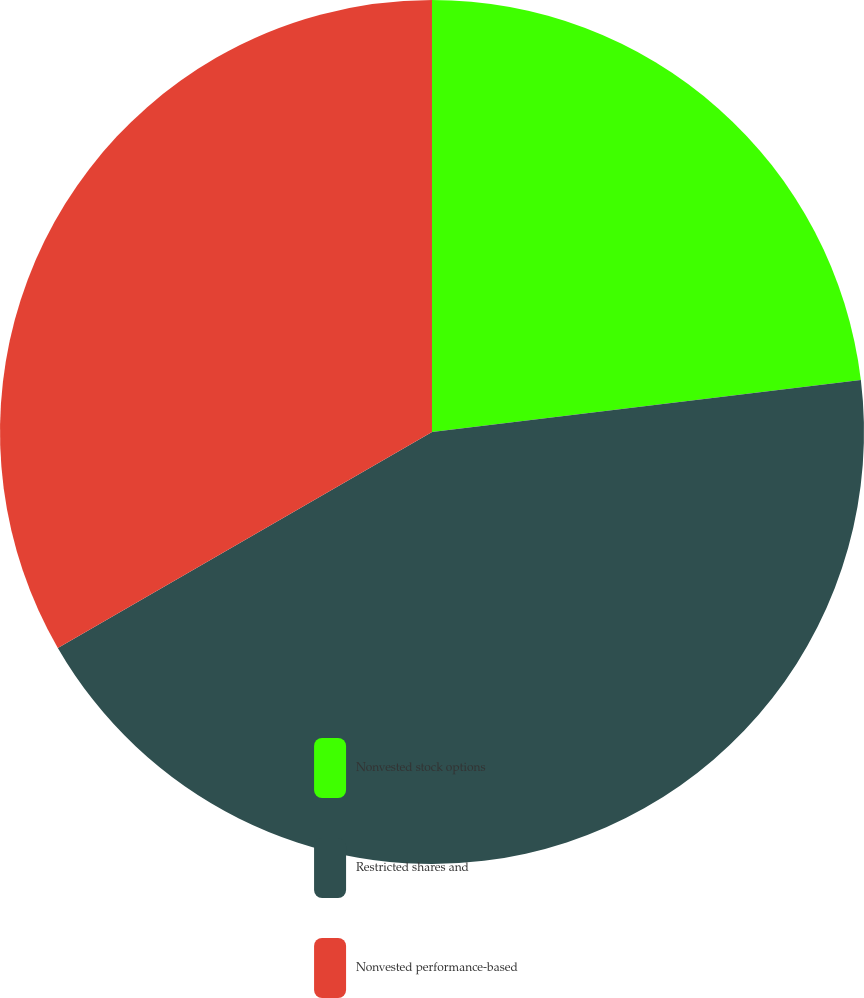<chart> <loc_0><loc_0><loc_500><loc_500><pie_chart><fcel>Nonvested stock options<fcel>Restricted shares and<fcel>Nonvested performance-based<nl><fcel>23.08%<fcel>43.59%<fcel>33.33%<nl></chart> 